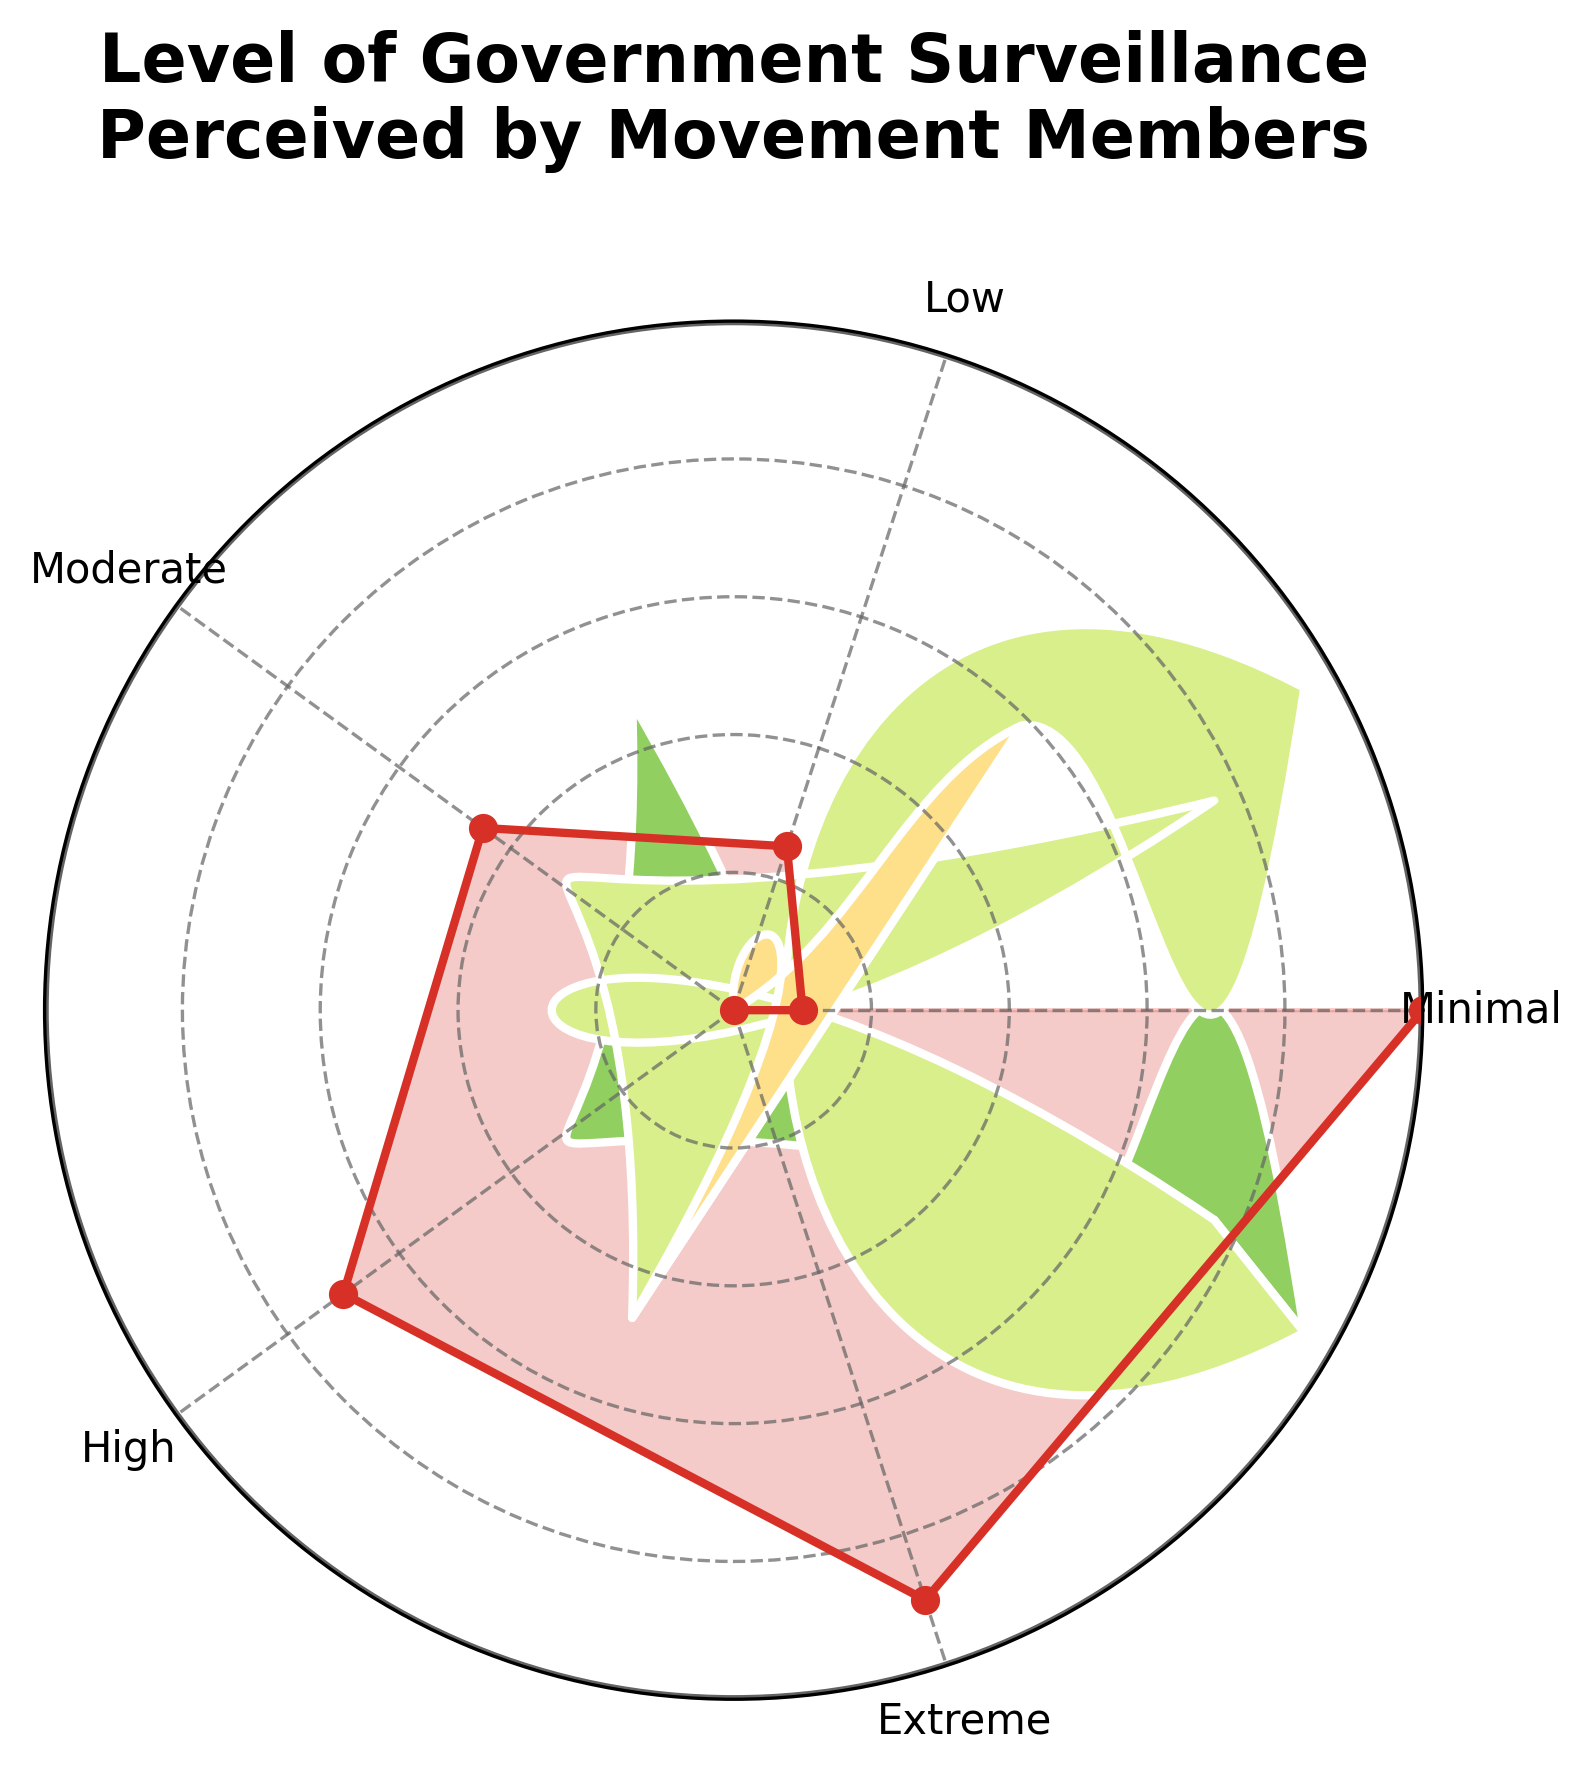What is the title of the gauge chart? The title of the gauge chart is located at the top of the figure. It reads: "Level of Government Surveillance Perceived by Movement Members".
Answer: Level of Government Surveillance Perceived by Movement Members Which level of surveillance has the highest perceived percentage? By examining the chart, the section labeled "Extreme" reaches the highest value on the gauge, at the upper end of the scale.
Answer: Extreme What is the percentage value for the 'Moderate' level of surveillance? The 'Moderate' level of surveillance is placed between the sections labeled "Low" and "High" on the gauge, and its corresponding value can be seen as 45%.
Answer: 45% How many different levels of surveillance are represented in the chart? By counting the distinct labels on the gauge's circular scale, we see the following levels: Minimal, Low, Moderate, High, and Extreme.
Answer: 5 Which level shows a 25% surveillance perception? The section of the gauge labeled as "Low" intersects with the 25% mark on the circular scale.
Answer: Low Is the perceived surveillance for 'High' greater than 'Moderate'? By how much? The gauge indicates that 'High' is at 70% and 'Moderate' is at 45%. Subtracting these values, we get 70% - 45% = 25%.
Answer: Yes, by 25% What is the average perceived surveillance percentage among all levels? The values for each level are: Minimal (10), Low (25), Moderate (45), High (70), Extreme (90). Summing these values gives 10 + 25 + 45 + 70 + 90 = 240. Dividing by the number of levels (5), we get an average: 240 / 5 = 48.
Answer: 48 Is the 'Minimal' level of perceived surveillance below 15%? Observing the 'Minimal' section on the gauge, it corresponds to a 10% perception value.
Answer: Yes Which two levels show the greatest difference in perceived surveillance? The levels with the maximum difference can be identified by looking at the two extreme ends of the gauge. 'Extreme' shows 90% and 'Minimal' shows 10%. The difference is calculated as 90% - 10% = 80%.
Answer: Extreme and Minimal Describe the color gradient used in the gauge chart for the different levels. The color gradient seen in the gauge chart transitions from green (Minimal level) to red (Extreme level), moving through shades of green, yellow, and orange in between. This suggests a progression from less to more perceived surveillance.
Answer: Green to red 